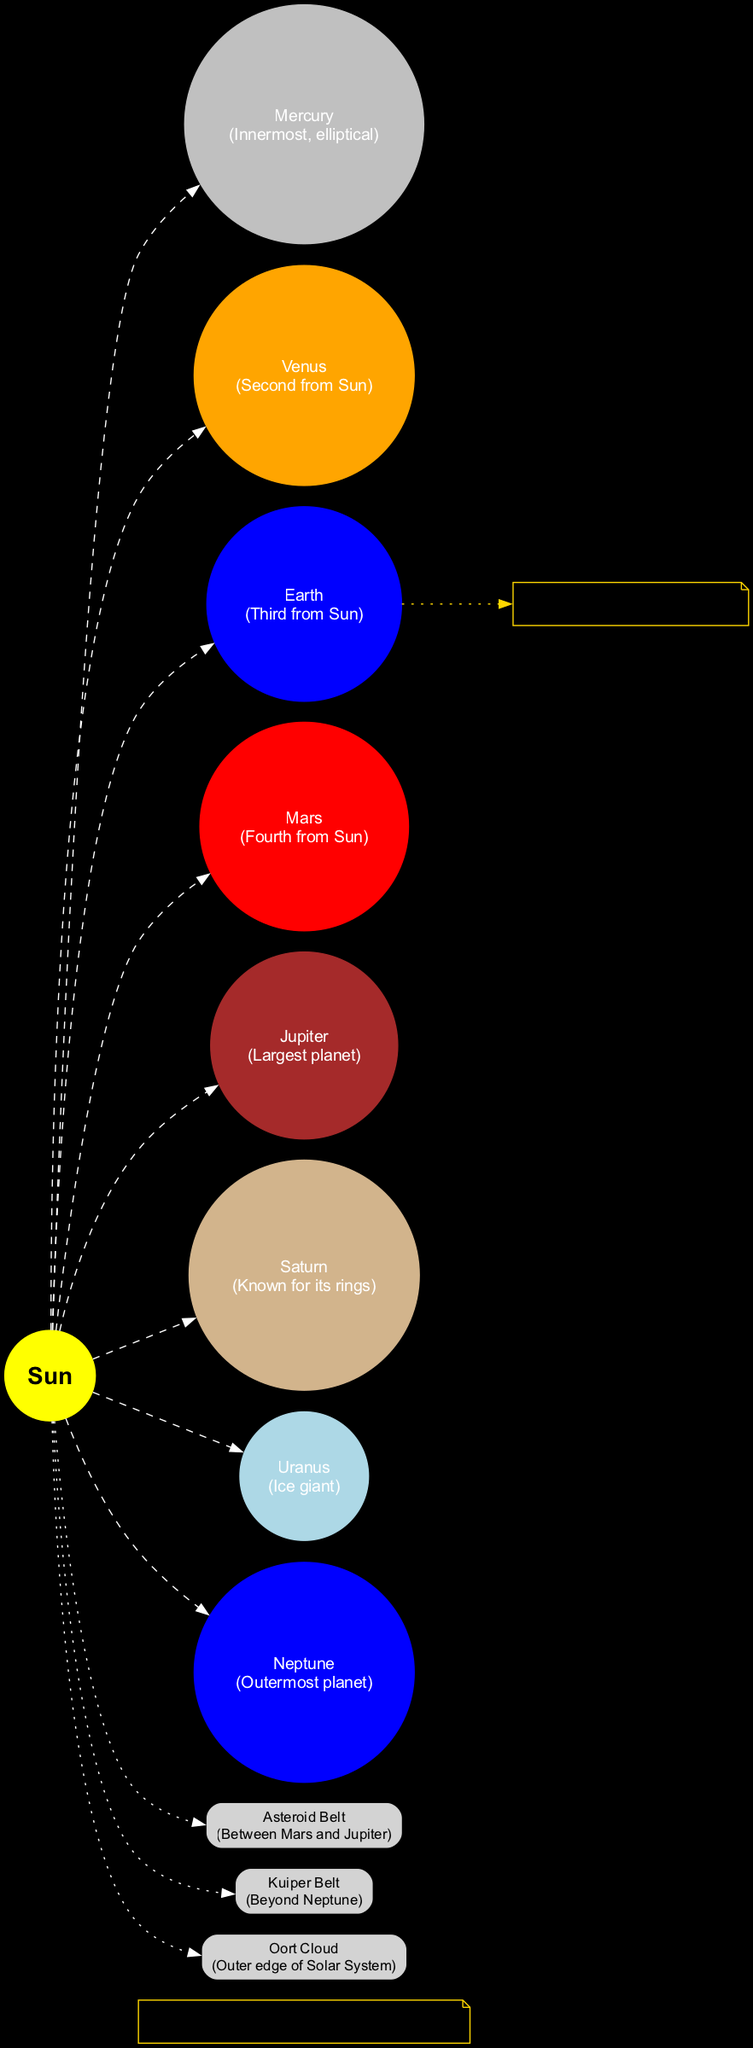What is the innermost planet in the Solar System? The diagram labels Mercury as the innermost planet, positioned closest to the Sun among all planets.
Answer: Mercury Which planet has the largest orbit? The diagram indicates that Jupiter is the largest planet. Thus, it holds the largest orbit when considering planetary size.
Answer: Jupiter Where is the Asteroid Belt located? The diagram specifies the location of the Asteroid Belt, indicating it is situated between Mars and Jupiter, clearly marked under the other bodies section.
Answer: Between Mars and Jupiter What celestial body is located beyond Neptune? According to the diagram, the Kuiper Belt is positioned beyond Neptune, among other celestial features.
Answer: Kuiper Belt Which planet is noted for having rings? The diagram highlights Saturn specifically for its rings, making it clear that this planet is recognized for that characteristic.
Answer: Saturn How many planets are there in the Solar System? The diagram includes eight planets, which are identified from Mercury to Neptune. Counting these reveals there are eight total.
Answer: Eight What note is associated with Earth? The diagram shows a note connected to Earth, stating it is the setting for the author's latest mystery novel, providing a personal touch.
Answer: Setting for my latest mystery novel What is located at the outer edge of the Solar System? The diagram identifies the Oort Cloud as located at the outer edge of the Solar System, among the other notable celestial features listed.
Answer: Oort Cloud Which major celestial body is the central focus of the diagram? The diagram prominently features the Sun as the center of the Solar System, clearly marked and styled to stand out in the visualization.
Answer: Sun 